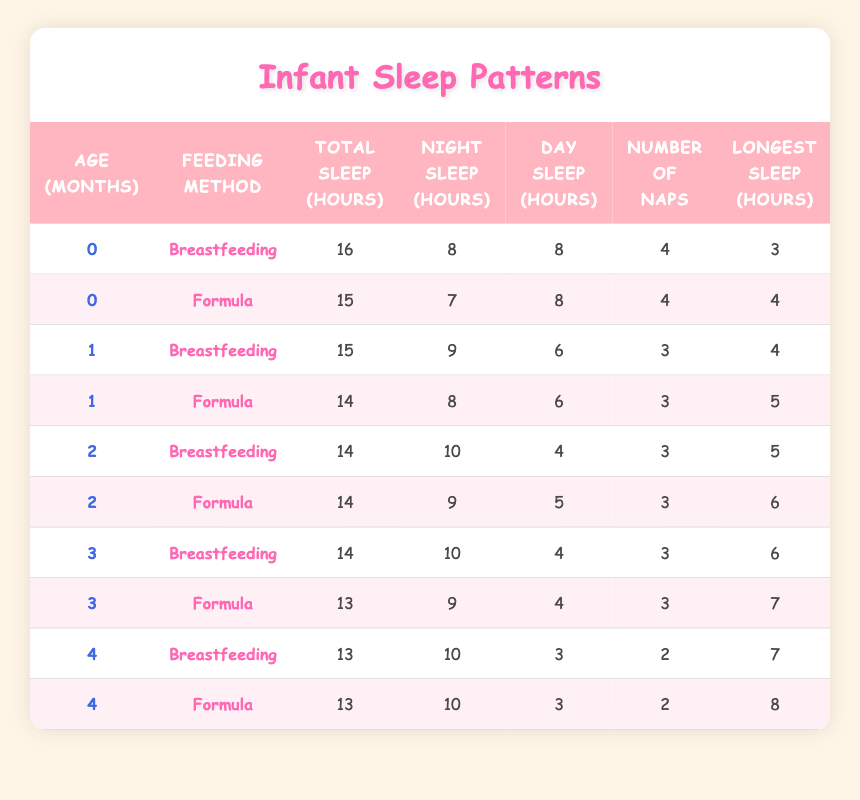What is the longest sleep stretch for a newborn (0 months) fed by breastfeeding? The table indicates the longest sleep stretch for a newborn (0 months) fed by breastfeeding is 3 hours. To find this, I checked the row where age is 0 and feeding method is Breastfeeding, which directly gives the value.
Answer: 3 How many total sleep hours do infants at 1 month have on average? For 1-month-old infants, there are two feeding methods recorded: Breastfeeding (15 hours) and Formula (14 hours). To calculate the average, I sum these values (15 + 14 = 29) and divide by the number of feeding methods (2), which gives us 29/2 = 14.5 hours.
Answer: 14.5 Is the total sleep for a 4-month-old infant fed by formula the same as that for one fed by breastfeeding? Checking the total sleep hours for both feeding methods at 4 months shows they both have 13 hours. Therefore, the statement is true since both values are equal.
Answer: Yes What is the difference in night sleep hours between infants fed by breastfeeding and formula at 3 months? For 3-month-old infants, the night sleep hours for breastfeeding is 10 hours and for formula is 9 hours. The difference is calculated by subtracting 9 from 10, which gives us 10 - 9 = 1 hour.
Answer: 1 What is the total number of naps taken by 2-month-old infants using breastfeeding? According to the table, both breastfeeding infants at 2 months have 3 naps recorded. Since there are two entries, the total remains 3 naps as this value is consistent across the rows.
Answer: 3 